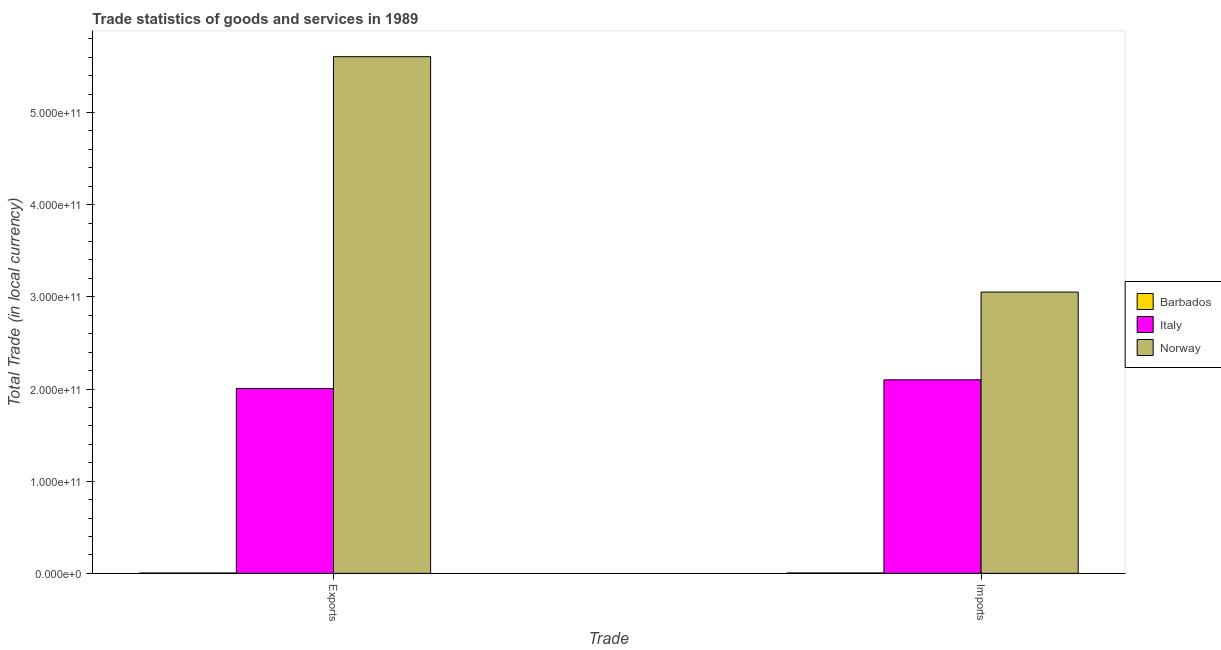Are the number of bars on each tick of the X-axis equal?
Ensure brevity in your answer.  Yes. What is the label of the 2nd group of bars from the left?
Offer a terse response. Imports. What is the imports of goods and services in Italy?
Your answer should be very brief. 2.10e+11. Across all countries, what is the maximum imports of goods and services?
Your answer should be compact. 3.05e+11. Across all countries, what is the minimum imports of goods and services?
Your answer should be very brief. 3.93e+08. In which country was the export of goods and services minimum?
Provide a succinct answer. Barbados. What is the total imports of goods and services in the graph?
Your answer should be compact. 5.16e+11. What is the difference between the export of goods and services in Italy and that in Norway?
Your answer should be very brief. -3.60e+11. What is the difference between the imports of goods and services in Italy and the export of goods and services in Barbados?
Keep it short and to the point. 2.10e+11. What is the average export of goods and services per country?
Keep it short and to the point. 2.54e+11. What is the difference between the export of goods and services and imports of goods and services in Italy?
Ensure brevity in your answer.  -9.41e+09. In how many countries, is the export of goods and services greater than 60000000000 LCU?
Ensure brevity in your answer.  2. What is the ratio of the imports of goods and services in Norway to that in Barbados?
Your answer should be compact. 776.47. In how many countries, is the imports of goods and services greater than the average imports of goods and services taken over all countries?
Provide a succinct answer. 2. What does the 2nd bar from the right in Exports represents?
Make the answer very short. Italy. How many bars are there?
Your response must be concise. 6. Are all the bars in the graph horizontal?
Keep it short and to the point. No. How many countries are there in the graph?
Your answer should be compact. 3. What is the difference between two consecutive major ticks on the Y-axis?
Offer a very short reply. 1.00e+11. Does the graph contain any zero values?
Make the answer very short. No. Where does the legend appear in the graph?
Your answer should be very brief. Center right. What is the title of the graph?
Ensure brevity in your answer.  Trade statistics of goods and services in 1989. Does "Canada" appear as one of the legend labels in the graph?
Offer a very short reply. No. What is the label or title of the X-axis?
Keep it short and to the point. Trade. What is the label or title of the Y-axis?
Offer a terse response. Total Trade (in local currency). What is the Total Trade (in local currency) in Barbados in Exports?
Ensure brevity in your answer.  3.24e+08. What is the Total Trade (in local currency) of Italy in Exports?
Your answer should be very brief. 2.01e+11. What is the Total Trade (in local currency) of Norway in Exports?
Keep it short and to the point. 5.61e+11. What is the Total Trade (in local currency) in Barbados in Imports?
Make the answer very short. 3.93e+08. What is the Total Trade (in local currency) of Italy in Imports?
Give a very brief answer. 2.10e+11. What is the Total Trade (in local currency) in Norway in Imports?
Ensure brevity in your answer.  3.05e+11. Across all Trade, what is the maximum Total Trade (in local currency) in Barbados?
Keep it short and to the point. 3.93e+08. Across all Trade, what is the maximum Total Trade (in local currency) of Italy?
Offer a very short reply. 2.10e+11. Across all Trade, what is the maximum Total Trade (in local currency) in Norway?
Provide a short and direct response. 5.61e+11. Across all Trade, what is the minimum Total Trade (in local currency) in Barbados?
Provide a succinct answer. 3.24e+08. Across all Trade, what is the minimum Total Trade (in local currency) of Italy?
Keep it short and to the point. 2.01e+11. Across all Trade, what is the minimum Total Trade (in local currency) of Norway?
Ensure brevity in your answer.  3.05e+11. What is the total Total Trade (in local currency) of Barbados in the graph?
Your response must be concise. 7.17e+08. What is the total Total Trade (in local currency) in Italy in the graph?
Ensure brevity in your answer.  4.11e+11. What is the total Total Trade (in local currency) of Norway in the graph?
Provide a succinct answer. 8.66e+11. What is the difference between the Total Trade (in local currency) in Barbados in Exports and that in Imports?
Offer a terse response. -6.90e+07. What is the difference between the Total Trade (in local currency) in Italy in Exports and that in Imports?
Your answer should be compact. -9.41e+09. What is the difference between the Total Trade (in local currency) in Norway in Exports and that in Imports?
Make the answer very short. 2.55e+11. What is the difference between the Total Trade (in local currency) in Barbados in Exports and the Total Trade (in local currency) in Italy in Imports?
Your answer should be very brief. -2.10e+11. What is the difference between the Total Trade (in local currency) of Barbados in Exports and the Total Trade (in local currency) of Norway in Imports?
Offer a very short reply. -3.05e+11. What is the difference between the Total Trade (in local currency) in Italy in Exports and the Total Trade (in local currency) in Norway in Imports?
Offer a terse response. -1.05e+11. What is the average Total Trade (in local currency) in Barbados per Trade?
Provide a succinct answer. 3.58e+08. What is the average Total Trade (in local currency) of Italy per Trade?
Keep it short and to the point. 2.05e+11. What is the average Total Trade (in local currency) in Norway per Trade?
Your response must be concise. 4.33e+11. What is the difference between the Total Trade (in local currency) in Barbados and Total Trade (in local currency) in Italy in Exports?
Ensure brevity in your answer.  -2.00e+11. What is the difference between the Total Trade (in local currency) in Barbados and Total Trade (in local currency) in Norway in Exports?
Ensure brevity in your answer.  -5.60e+11. What is the difference between the Total Trade (in local currency) of Italy and Total Trade (in local currency) of Norway in Exports?
Provide a short and direct response. -3.60e+11. What is the difference between the Total Trade (in local currency) of Barbados and Total Trade (in local currency) of Italy in Imports?
Provide a succinct answer. -2.10e+11. What is the difference between the Total Trade (in local currency) of Barbados and Total Trade (in local currency) of Norway in Imports?
Provide a succinct answer. -3.05e+11. What is the difference between the Total Trade (in local currency) of Italy and Total Trade (in local currency) of Norway in Imports?
Your answer should be very brief. -9.52e+1. What is the ratio of the Total Trade (in local currency) in Barbados in Exports to that in Imports?
Make the answer very short. 0.82. What is the ratio of the Total Trade (in local currency) of Italy in Exports to that in Imports?
Ensure brevity in your answer.  0.96. What is the ratio of the Total Trade (in local currency) in Norway in Exports to that in Imports?
Your answer should be compact. 1.84. What is the difference between the highest and the second highest Total Trade (in local currency) of Barbados?
Your answer should be compact. 6.90e+07. What is the difference between the highest and the second highest Total Trade (in local currency) of Italy?
Keep it short and to the point. 9.41e+09. What is the difference between the highest and the second highest Total Trade (in local currency) in Norway?
Give a very brief answer. 2.55e+11. What is the difference between the highest and the lowest Total Trade (in local currency) of Barbados?
Make the answer very short. 6.90e+07. What is the difference between the highest and the lowest Total Trade (in local currency) of Italy?
Keep it short and to the point. 9.41e+09. What is the difference between the highest and the lowest Total Trade (in local currency) of Norway?
Make the answer very short. 2.55e+11. 